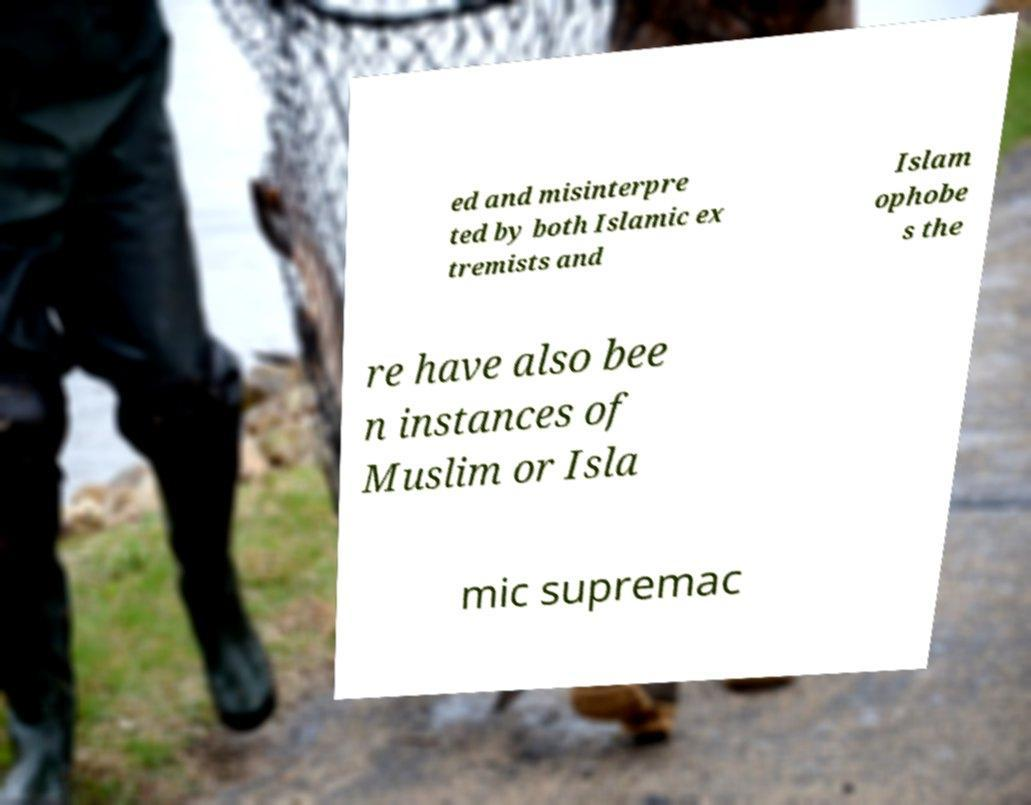Could you assist in decoding the text presented in this image and type it out clearly? ed and misinterpre ted by both Islamic ex tremists and Islam ophobe s the re have also bee n instances of Muslim or Isla mic supremac 